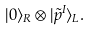<formula> <loc_0><loc_0><loc_500><loc_500>| 0 \rangle _ { R } \otimes | \tilde { p } ^ { I } \rangle _ { L } .</formula> 